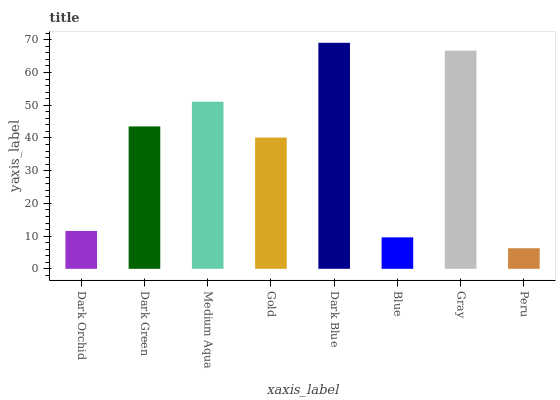Is Peru the minimum?
Answer yes or no. Yes. Is Dark Blue the maximum?
Answer yes or no. Yes. Is Dark Green the minimum?
Answer yes or no. No. Is Dark Green the maximum?
Answer yes or no. No. Is Dark Green greater than Dark Orchid?
Answer yes or no. Yes. Is Dark Orchid less than Dark Green?
Answer yes or no. Yes. Is Dark Orchid greater than Dark Green?
Answer yes or no. No. Is Dark Green less than Dark Orchid?
Answer yes or no. No. Is Dark Green the high median?
Answer yes or no. Yes. Is Gold the low median?
Answer yes or no. Yes. Is Gold the high median?
Answer yes or no. No. Is Dark Blue the low median?
Answer yes or no. No. 